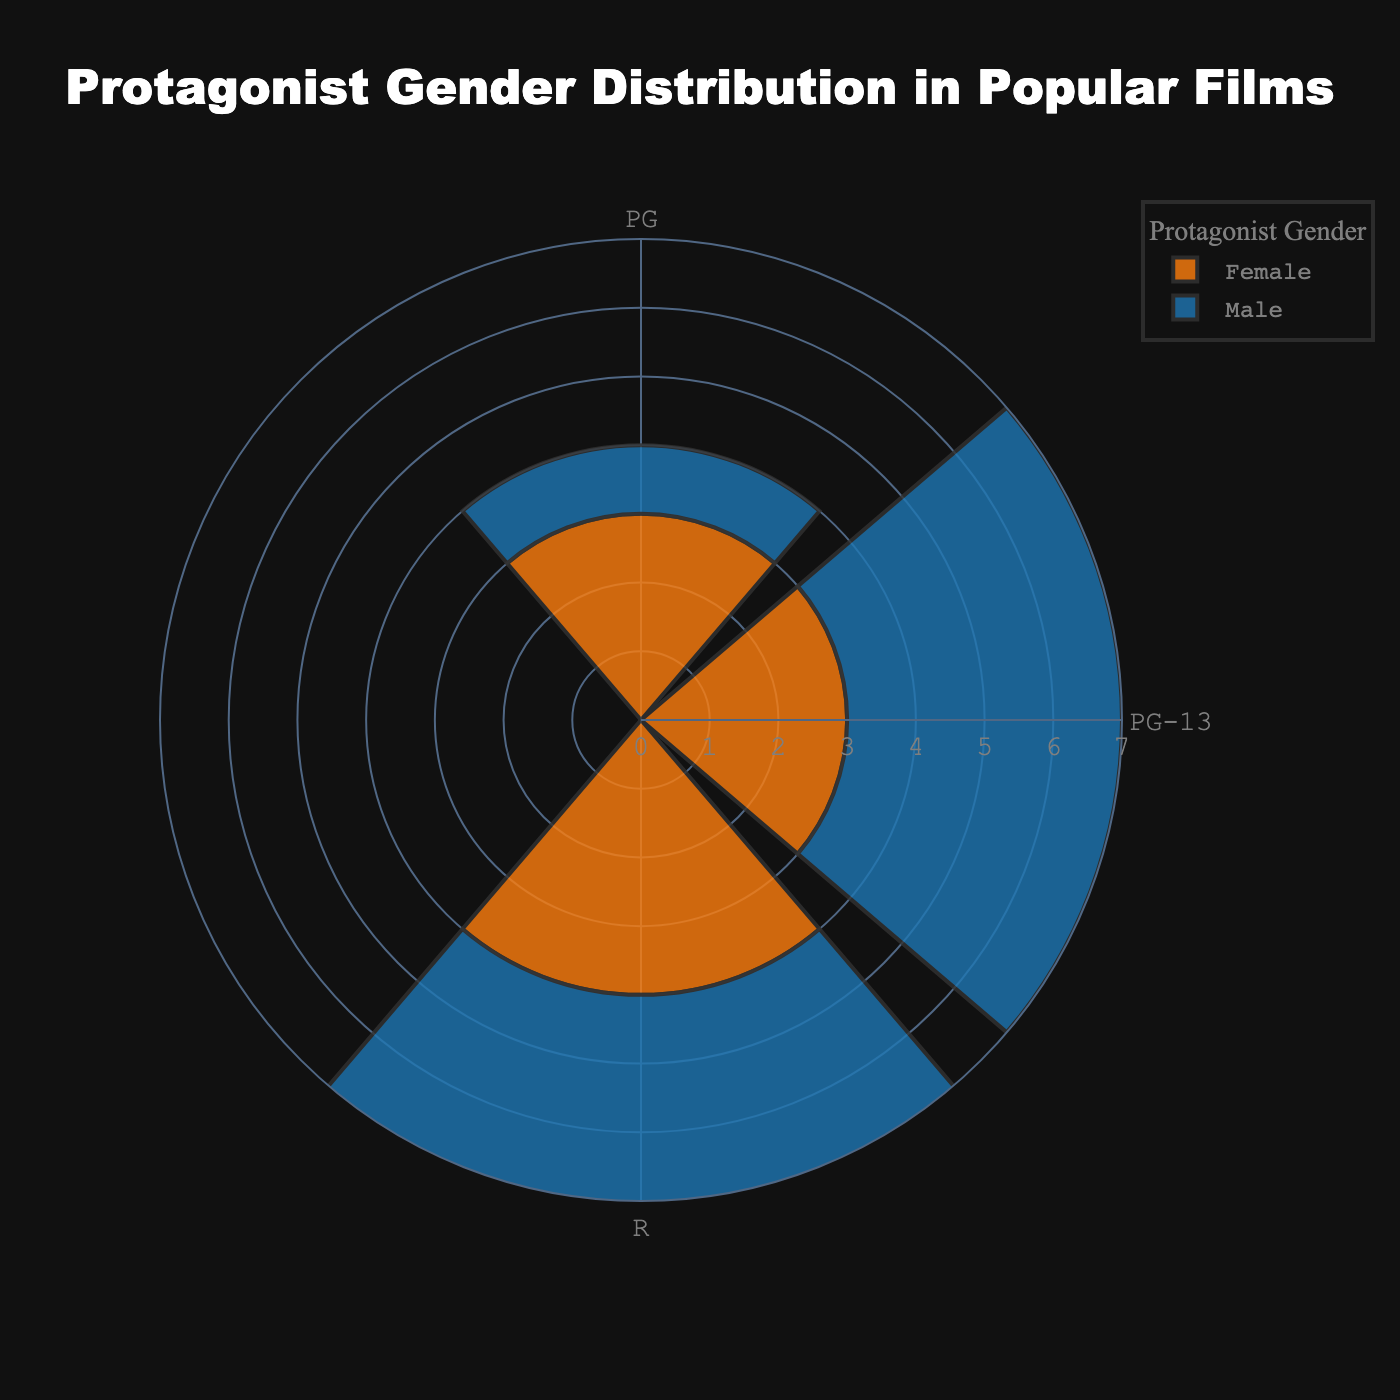What's the title of the figure? Look at the top of the figure, the title is typically displayed there.
Answer: Protagonist Gender Distribution in Popular Films What rating has the most female protagonists? Observe the bars labeled by gender and rating, then compare the cumulative heights.
Answer: PG Which gender has a higher protagonist count in PG-13 rated films? Compare the bar lengths corresponding to 'Male' and 'Female' in PG-13 rating.
Answer: Male What is the total count of male protagonists across all ratings? Sum the counts of male protagonists in all ratings by adding the respective bar lengths.
Answer: 7 Which rating has the highest count of protagonists? Look for the rating that has the highest cumulative bar heights across all genders.
Answer: PG-13 What is the difference in count between male and female protagonists in R rated films? Calculate the difference by subtracting the count of female protagonists from that of male protagonists in R rating.
Answer: 3 Considering PG-rated films, what's the ratio of female protagonists to male protagonists? Divide the count of female protagonists by the count of male protagonists in PG rating.
Answer: 3:1 In which rating category do male and female protagonists have the same count? Check if any rating has equal bar heights for both genders.
Answer: None How many total protagonists are there in PG-13 rated films? Sum the counts of both male and female protagonists in PG-13 rating.
Answer: 7 Which rating category has the least number of female protagonists? Identify the rating with the shortest bar for female protagonists.
Answer: R 